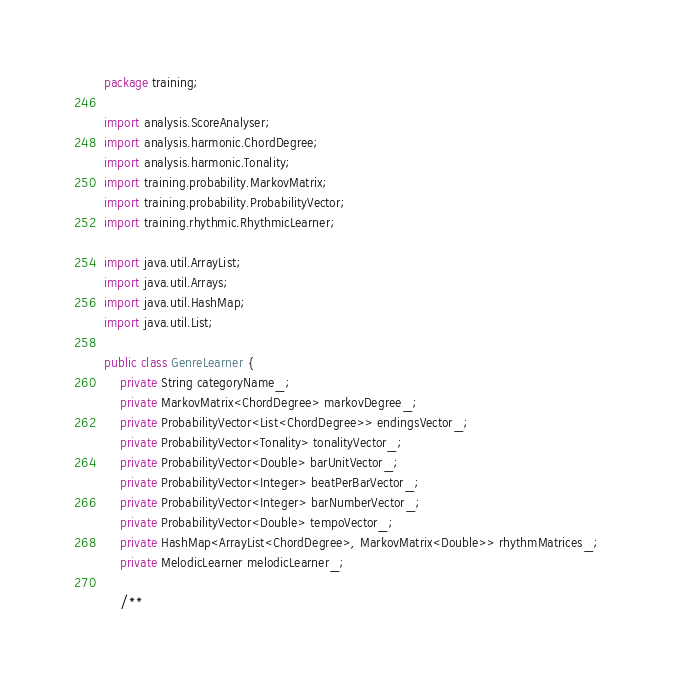Convert code to text. <code><loc_0><loc_0><loc_500><loc_500><_Java_>package training;

import analysis.ScoreAnalyser;
import analysis.harmonic.ChordDegree;
import analysis.harmonic.Tonality;
import training.probability.MarkovMatrix;
import training.probability.ProbabilityVector;
import training.rhythmic.RhythmicLearner;

import java.util.ArrayList;
import java.util.Arrays;
import java.util.HashMap;
import java.util.List;

public class GenreLearner {
    private String categoryName_;
    private MarkovMatrix<ChordDegree> markovDegree_;
    private ProbabilityVector<List<ChordDegree>> endingsVector_;
    private ProbabilityVector<Tonality> tonalityVector_;
    private ProbabilityVector<Double> barUnitVector_;
    private ProbabilityVector<Integer> beatPerBarVector_;
    private ProbabilityVector<Integer> barNumberVector_;
    private ProbabilityVector<Double> tempoVector_;
    private HashMap<ArrayList<ChordDegree>, MarkovMatrix<Double>> rhythmMatrices_;
    private MelodicLearner melodicLearner_;

    /**</code> 